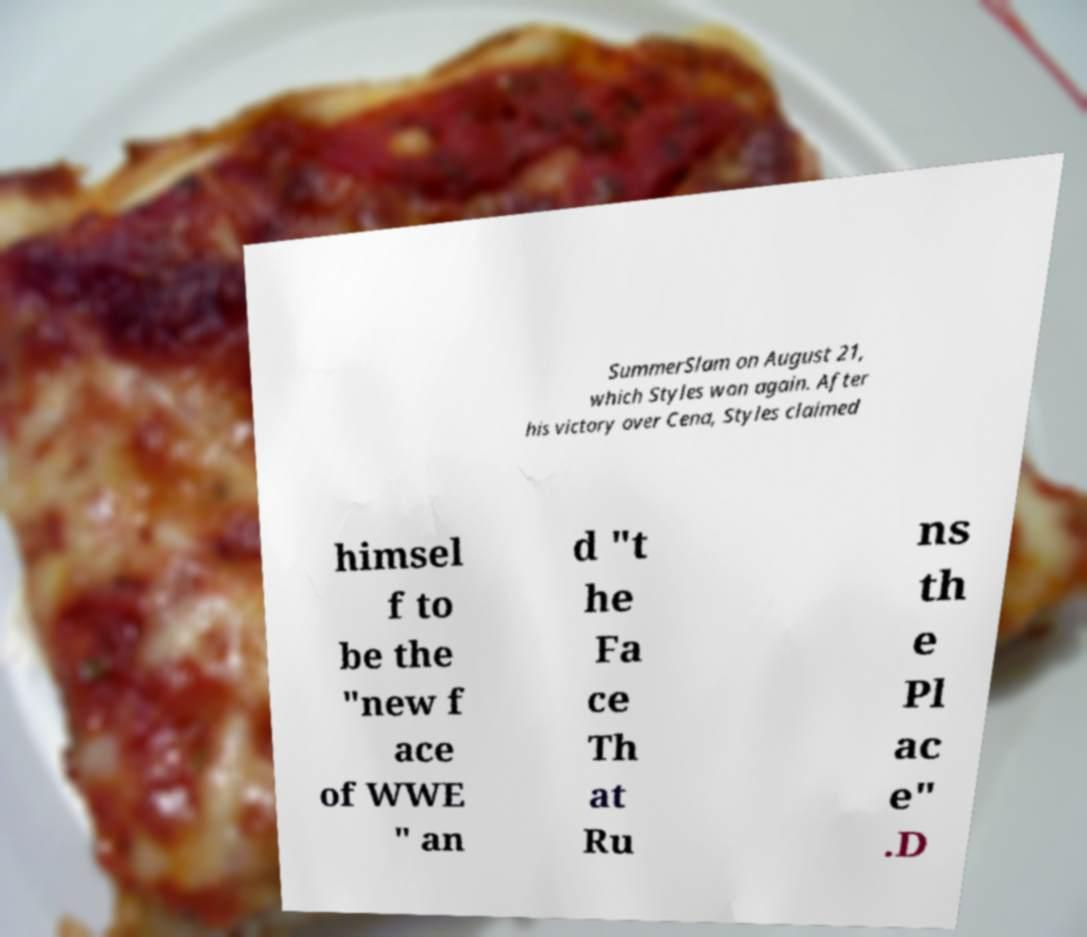Please read and relay the text visible in this image. What does it say? SummerSlam on August 21, which Styles won again. After his victory over Cena, Styles claimed himsel f to be the "new f ace of WWE " an d "t he Fa ce Th at Ru ns th e Pl ac e" .D 